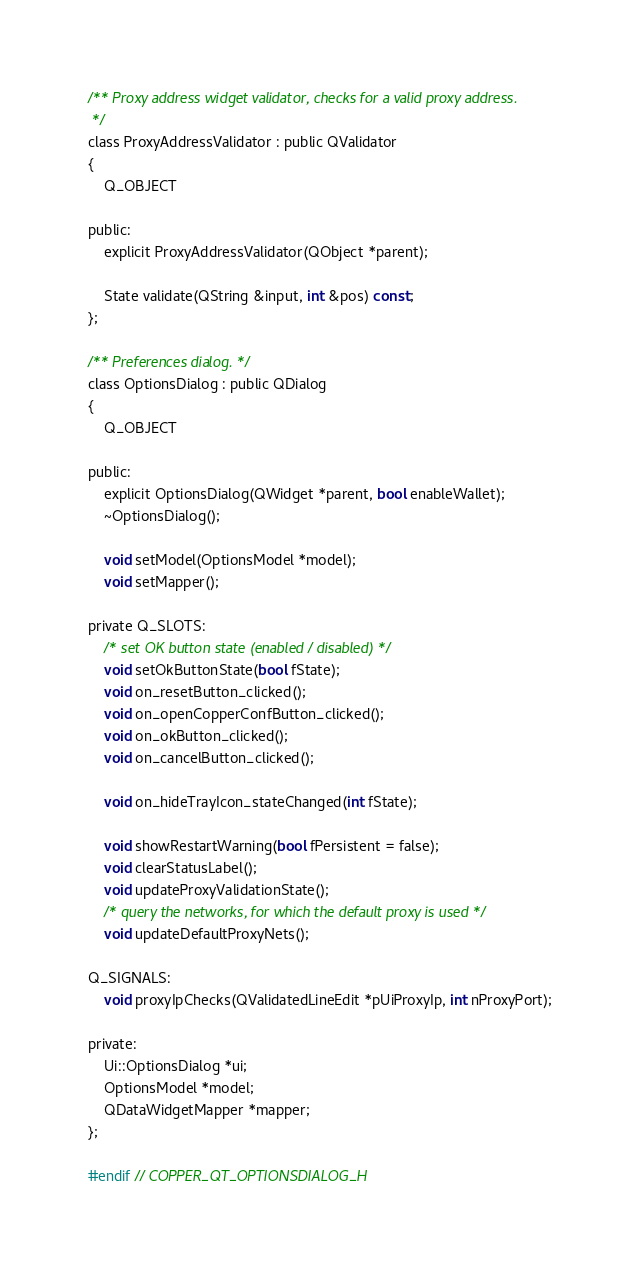Convert code to text. <code><loc_0><loc_0><loc_500><loc_500><_C_>/** Proxy address widget validator, checks for a valid proxy address.
 */
class ProxyAddressValidator : public QValidator
{
    Q_OBJECT

public:
    explicit ProxyAddressValidator(QObject *parent);

    State validate(QString &input, int &pos) const;
};

/** Preferences dialog. */
class OptionsDialog : public QDialog
{
    Q_OBJECT

public:
    explicit OptionsDialog(QWidget *parent, bool enableWallet);
    ~OptionsDialog();

    void setModel(OptionsModel *model);
    void setMapper();

private Q_SLOTS:
    /* set OK button state (enabled / disabled) */
    void setOkButtonState(bool fState);
    void on_resetButton_clicked();
    void on_openCopperConfButton_clicked();
    void on_okButton_clicked();
    void on_cancelButton_clicked();
    
    void on_hideTrayIcon_stateChanged(int fState);

    void showRestartWarning(bool fPersistent = false);
    void clearStatusLabel();
    void updateProxyValidationState();
    /* query the networks, for which the default proxy is used */
    void updateDefaultProxyNets();

Q_SIGNALS:
    void proxyIpChecks(QValidatedLineEdit *pUiProxyIp, int nProxyPort);

private:
    Ui::OptionsDialog *ui;
    OptionsModel *model;
    QDataWidgetMapper *mapper;
};

#endif // COPPER_QT_OPTIONSDIALOG_H
</code> 